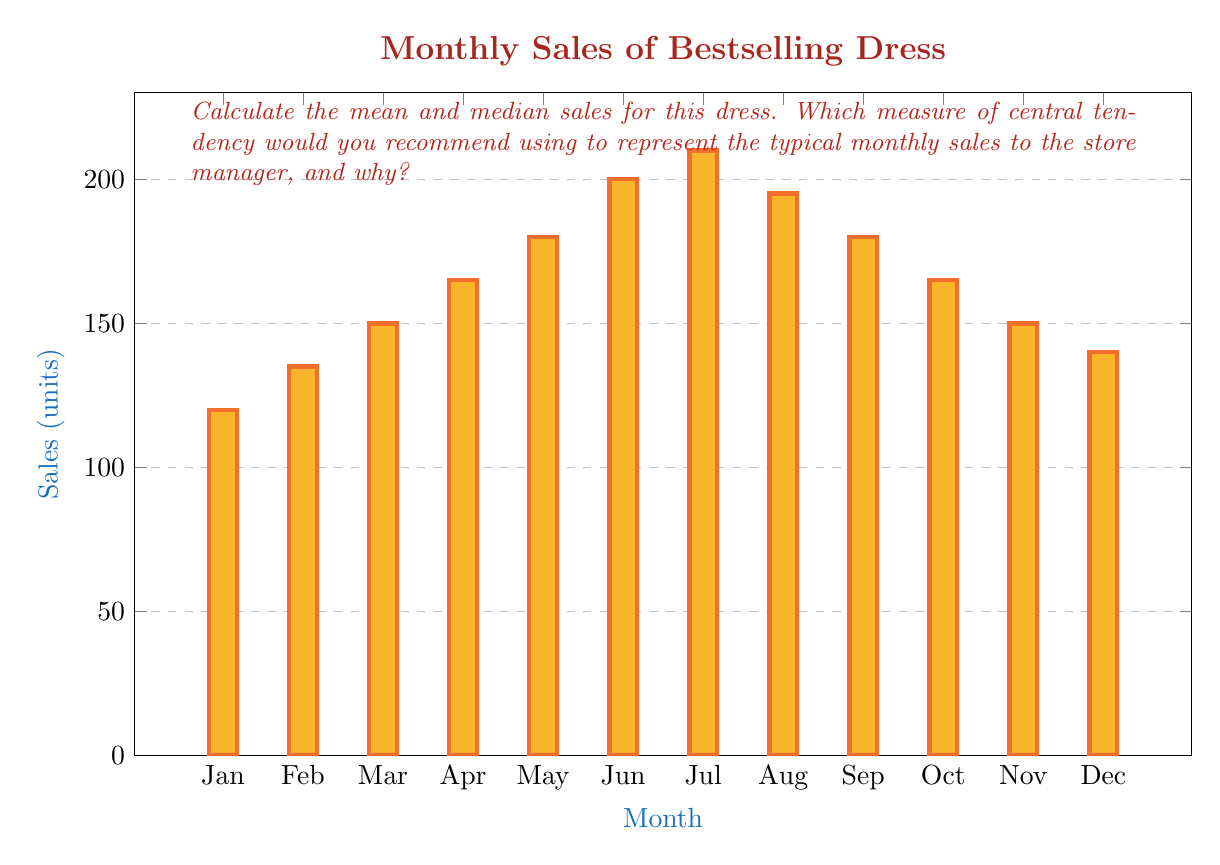Help me with this question. Let's approach this step-by-step:

1) First, let's calculate the mean:

   Mean = $\frac{\text{Sum of all values}}{\text{Number of values}}$

   Sum of sales = 120 + 135 + 150 + 165 + 180 + 200 + 210 + 195 + 180 + 165 + 150 + 140 = 1990
   Number of months = 12

   Mean = $\frac{1990}{12} = 165.83$ (rounded to 2 decimal places)

2) Now, let's find the median:
   
   First, we need to arrange the data in ascending order:
   120, 135, 140, 150, 150, 165, 165, 180, 180, 195, 200, 210

   Since we have an even number of values (12), the median will be the average of the 6th and 7th values:

   Median = $\frac{165 + 165}{2} = 165$

3) Comparison and recommendation:

   The mean (165.83) and median (165) are very close, indicating that the data is fairly symmetrical.

   However, the mean is slightly higher than the median, suggesting a slight positive skew in the data. This is likely due to the higher sales figures in the summer months (June, July, August).

   For this data set, the median might be a better representation of typical monthly sales because:

   a) It's less affected by extreme values (like the peak in July).
   b) It represents the middle value, which might be more relevant for inventory planning.
   c) It's a whole number, which is more practical when talking about unit sales.

   The mean, while close, is pulled slightly higher by the summer peak and might slightly overestimate the typical monthly sales.
Answer: Median: 165 units. It's less affected by extreme values and represents the middle of the data set. 